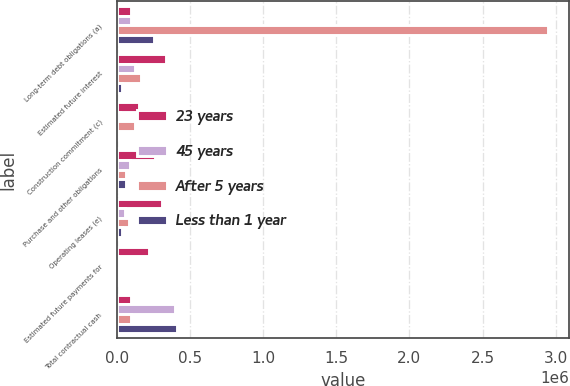<chart> <loc_0><loc_0><loc_500><loc_500><stacked_bar_chart><ecel><fcel>Long-term debt obligations (a)<fcel>Estimated future interest<fcel>Construction commitment (c)<fcel>Purchase and other obligations<fcel>Operating leases (e)<fcel>Estimated future payments for<fcel>Total contractual cash<nl><fcel>23 years<fcel>99312<fcel>336485<fcel>153000<fcel>261337<fcel>306737<fcel>222609<fcel>99312<nl><fcel>45 years<fcel>99312<fcel>123120<fcel>22000<fcel>87427<fcel>55812<fcel>9121<fcel>396792<nl><fcel>After 5 years<fcel>2.94383e+06<fcel>165904<fcel>126000<fcel>64340<fcel>83576<fcel>14373<fcel>99312<nl><fcel>Less than 1 year<fcel>253691<fcel>32818<fcel>5000<fcel>65700<fcel>38713<fcel>15164<fcel>411086<nl></chart> 